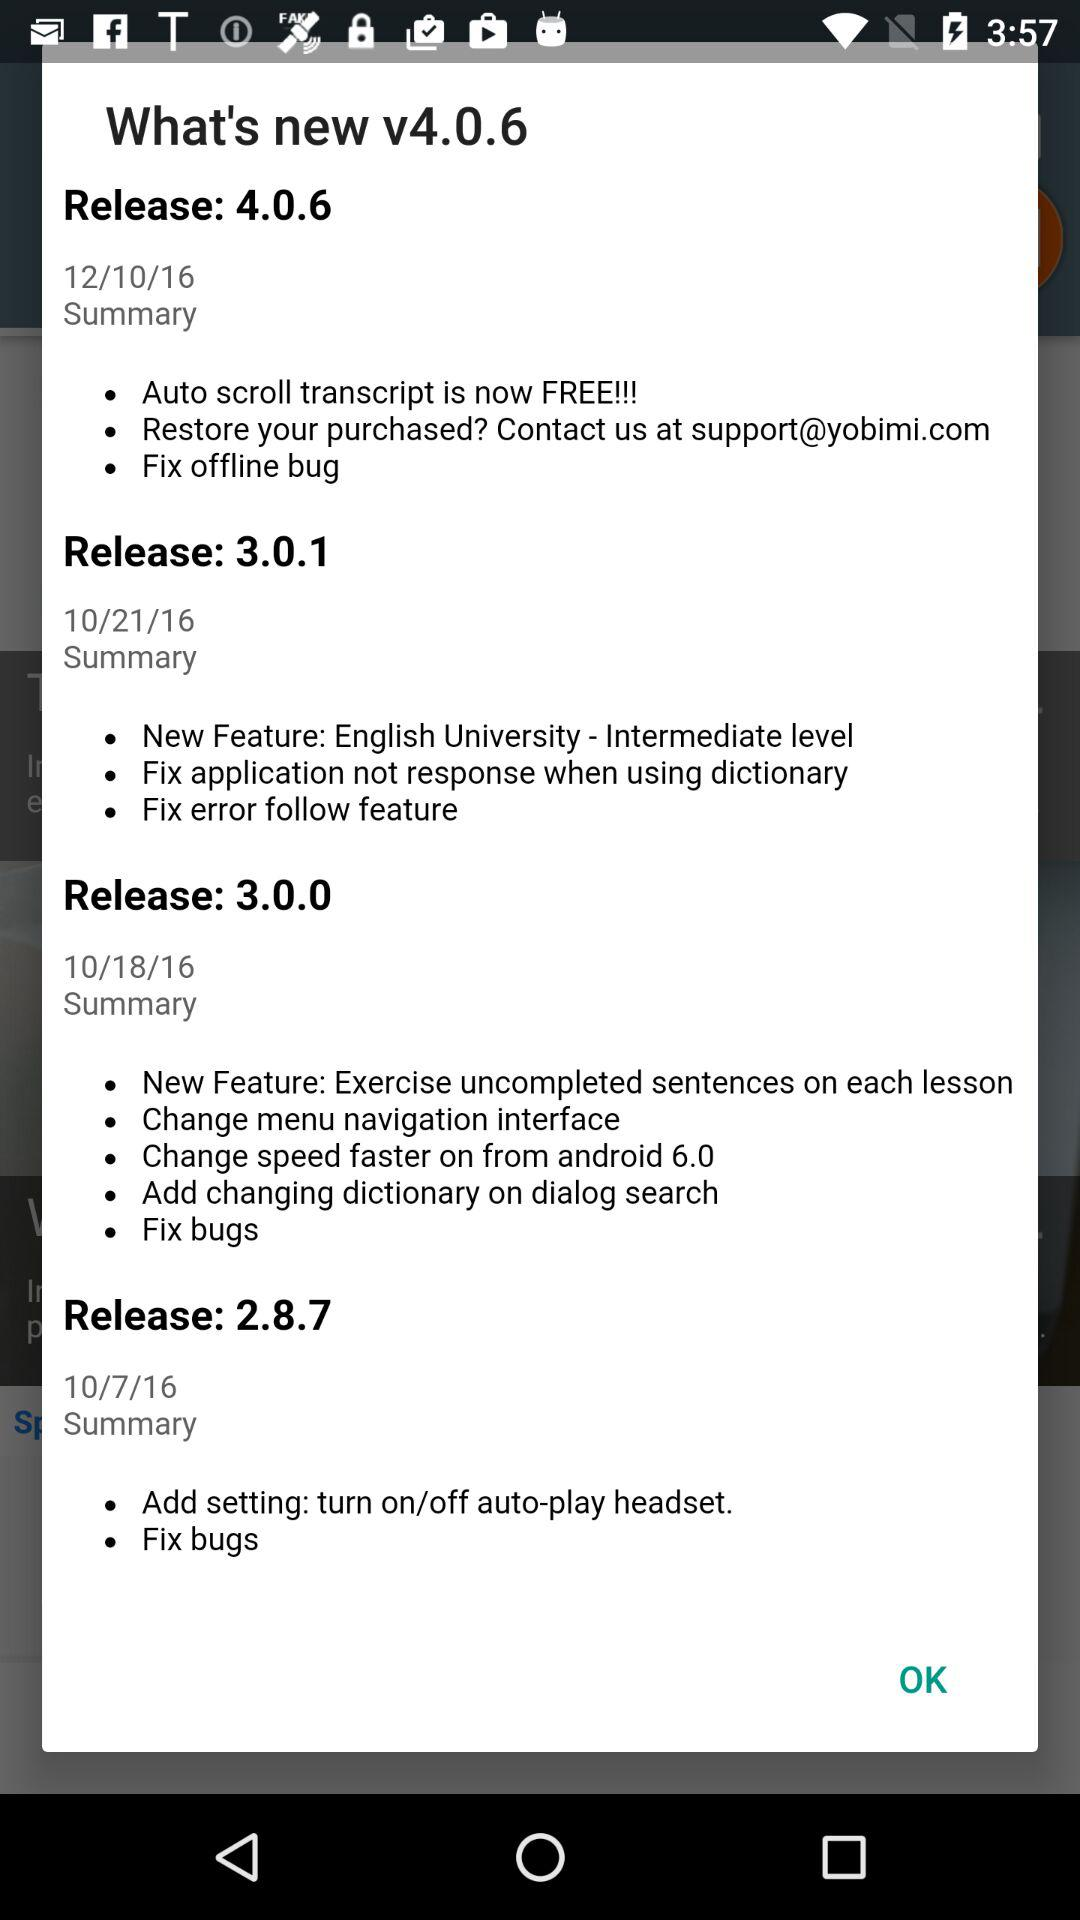What are the updates in "Release: 3.0.0"? The updates are "New Feature: Exercise uncompleted sentences on each lesson", "Change menu navigation interface", "Change speed faster on from android 6.0", "Add changing dictionary on dialog search" and "Fix bugs". 